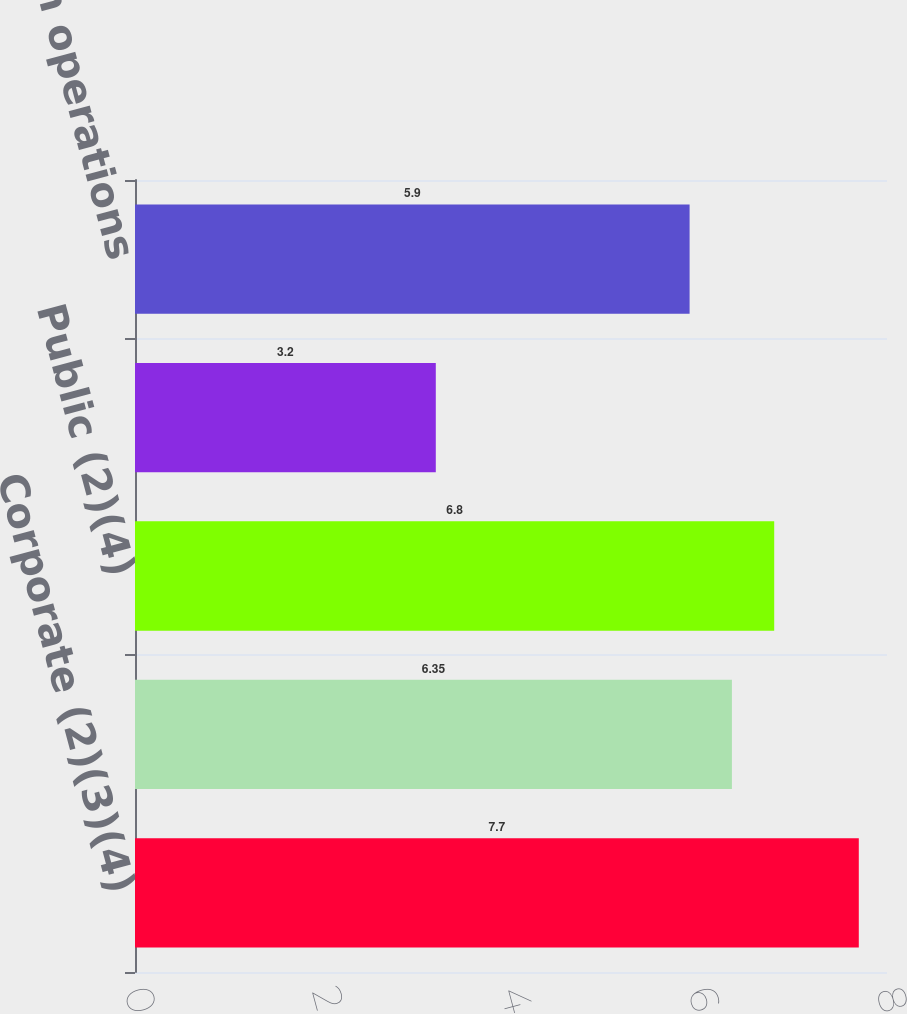Convert chart. <chart><loc_0><loc_0><loc_500><loc_500><bar_chart><fcel>Corporate (2)(3)(4)<fcel>Small Business (2)(3)(4)<fcel>Public (2)(4)<fcel>Other (4)(5)<fcel>Total Income from operations<nl><fcel>7.7<fcel>6.35<fcel>6.8<fcel>3.2<fcel>5.9<nl></chart> 